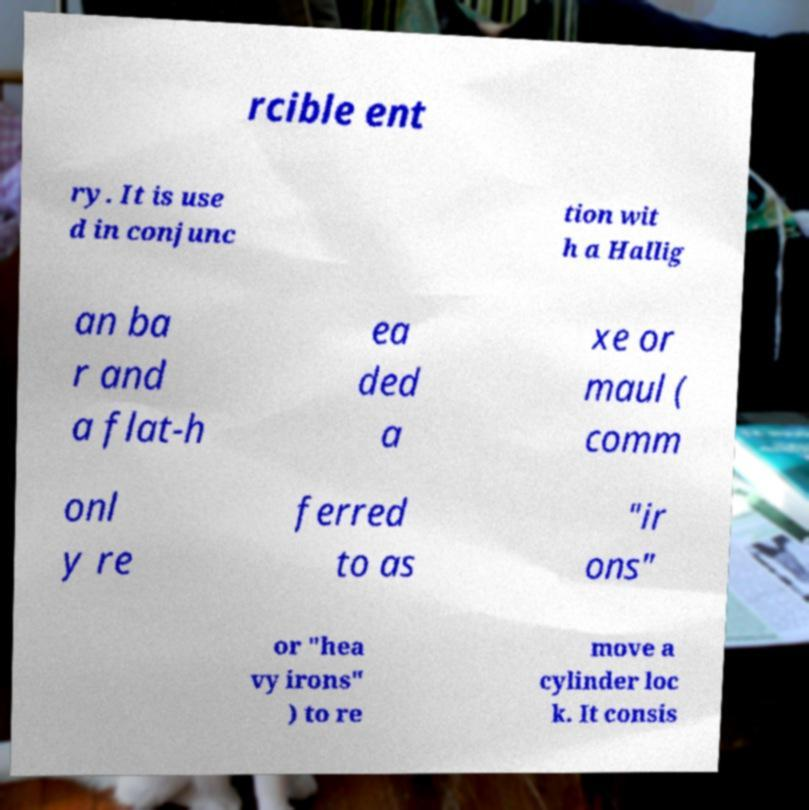Please identify and transcribe the text found in this image. rcible ent ry. It is use d in conjunc tion wit h a Hallig an ba r and a flat-h ea ded a xe or maul ( comm onl y re ferred to as "ir ons" or "hea vy irons" ) to re move a cylinder loc k. It consis 